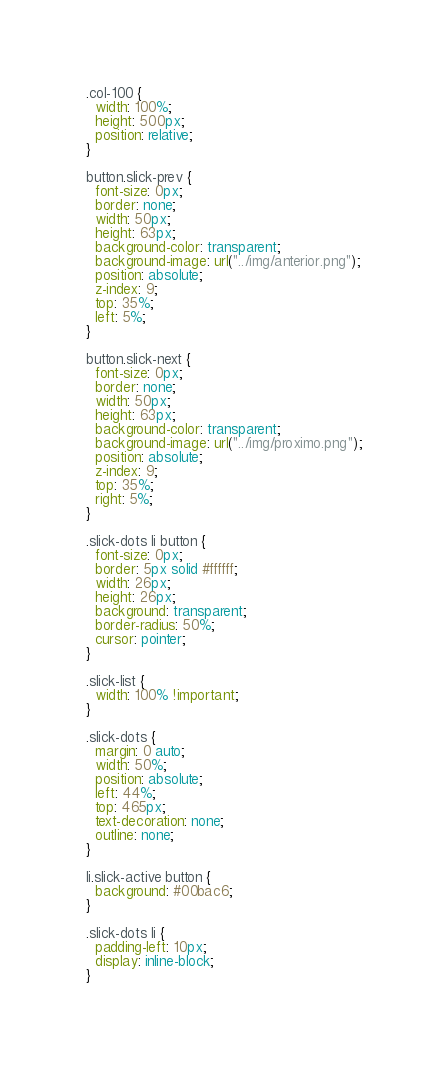Convert code to text. <code><loc_0><loc_0><loc_500><loc_500><_CSS_>.col-100 {
  width: 100%;
  height: 500px;
  position: relative;
}

button.slick-prev {
  font-size: 0px;
  border: none;
  width: 50px;
  height: 63px;
  background-color: transparent;
  background-image: url("../img/anterior.png");
  position: absolute;
  z-index: 9;
  top: 35%;
  left: 5%;
}

button.slick-next {
  font-size: 0px;
  border: none;
  width: 50px;
  height: 63px;
  background-color: transparent;
  background-image: url("../img/proximo.png");
  position: absolute;
  z-index: 9;
  top: 35%;
  right: 5%;
}

.slick-dots li button {
  font-size: 0px;
  border: 5px solid #ffffff;
  width: 26px;
  height: 26px;
  background: transparent;
  border-radius: 50%;
  cursor: pointer;
}

.slick-list {
  width: 100% !important;
}

.slick-dots {
  margin: 0 auto;
  width: 50%;
  position: absolute;
  left: 44%;
  top: 465px;
  text-decoration: none;
  outline: none;
}

li.slick-active button {
  background: #00bac6;
}

.slick-dots li {
  padding-left: 10px;
  display: inline-block;
}
</code> 